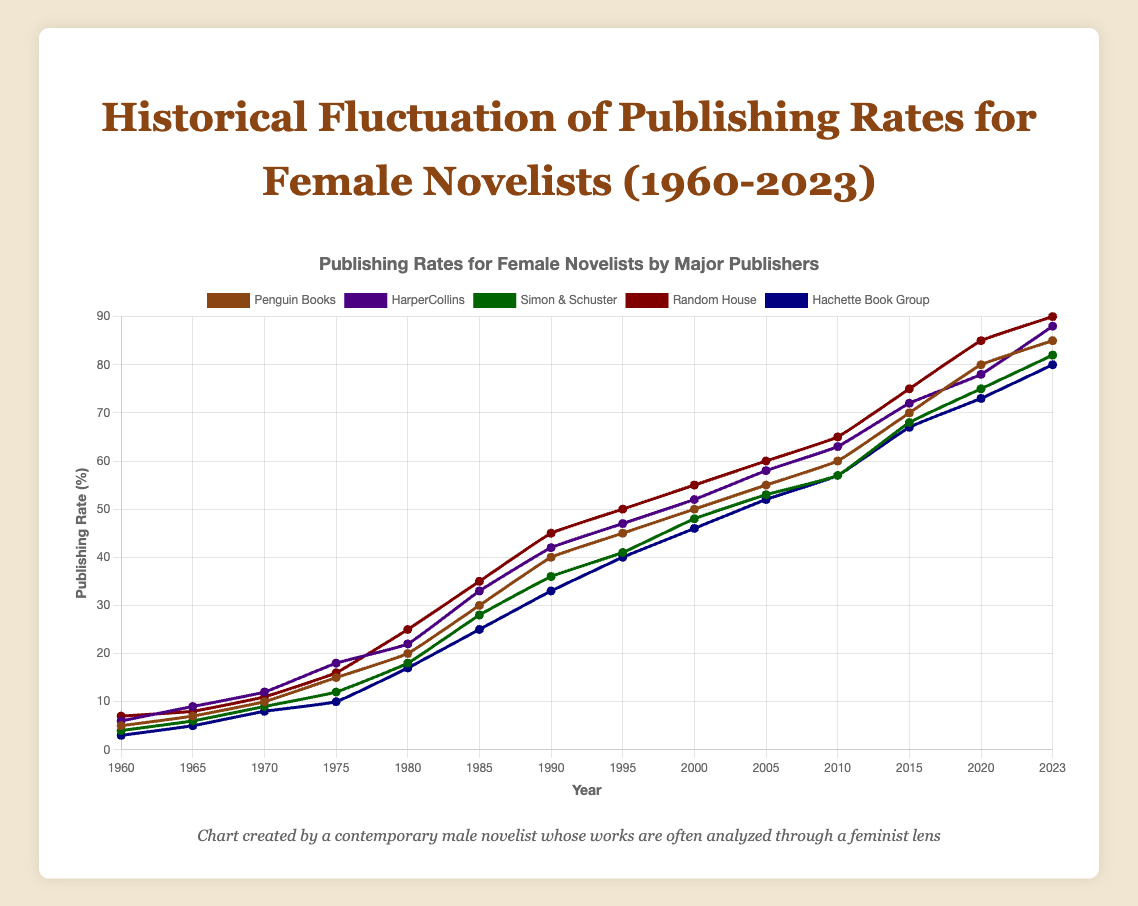Which publisher had the highest publishing rate for female novelists in 2023? Look at the end of each line representing the different publishers in the year 2023 and identify which one is the highest. Random House reaches 90%, which is higher than the others.
Answer: Random House How did the publishing rate for female novelists change for HarperCollins between 1980 and 2000? Check HarperCollins' publishing rates in 1980 and 2000, then calculate the difference: 52% (2000) - 22% (1980) = 30%.
Answer: Increased by 30% Between 1960 and 2023, which publisher showed the greatest overall increase in the publishing rate for female novelists? Calculate the difference between the publishing rates in 1960 and 2023 for each publisher. Random House had the highest increase from 7% to 90%, which is an increase of 83%.
Answer: Random House What was the average publishing rate for female novelists across all publishers in 1980? Sum the 1980 publishing rates and divide by the number of publishers: (20% + 22% + 18% + 25% + 17%) / 5 = 20.4%.
Answer: 20.4% How many publishers had a publishing rate of 50% or higher by 2000? Check the 2000 values and count the number of publishers with rates at or above 50%: Penguin Books (50%), HarperCollins (52%), and Random House (55%) are above 50%.
Answer: 3 Which publisher had the lowest publishing rate in 1975, and what was it? Look at the rates for all publishers in 1975 and identify the lowest. Hachette Book Group had the lowest rate at 10%.
Answer: Hachette Book Group, 10% Compared to 2010, did Simon & Schuster's publishing rate for female novelists increase or decrease by 2023, and by how much? Check Simon & Schuster's rates in 2010 and 2023, then calculate the difference: 82% (2023) - 57% (2010) = 25%.
Answer: Increased by 25% What is the sum of the publishing rates for Penguin Books and Hachette Book Group in 1985? Add the two rates from 1985: 30% (Penguin Books) + 25% (Hachette Book Group) = 55%.
Answer: 55% Which publisher had the most significant increase in the publishing rate for female novelists between 2000 and 2023? Calculate the increase for each publisher from 2000 to 2023 and find the largest. Random House increased from 55% to 90%, the largest change of 35%.
Answer: Random House 